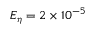Convert formula to latex. <formula><loc_0><loc_0><loc_500><loc_500>E _ { \eta } = 2 \times 1 0 ^ { - 5 }</formula> 